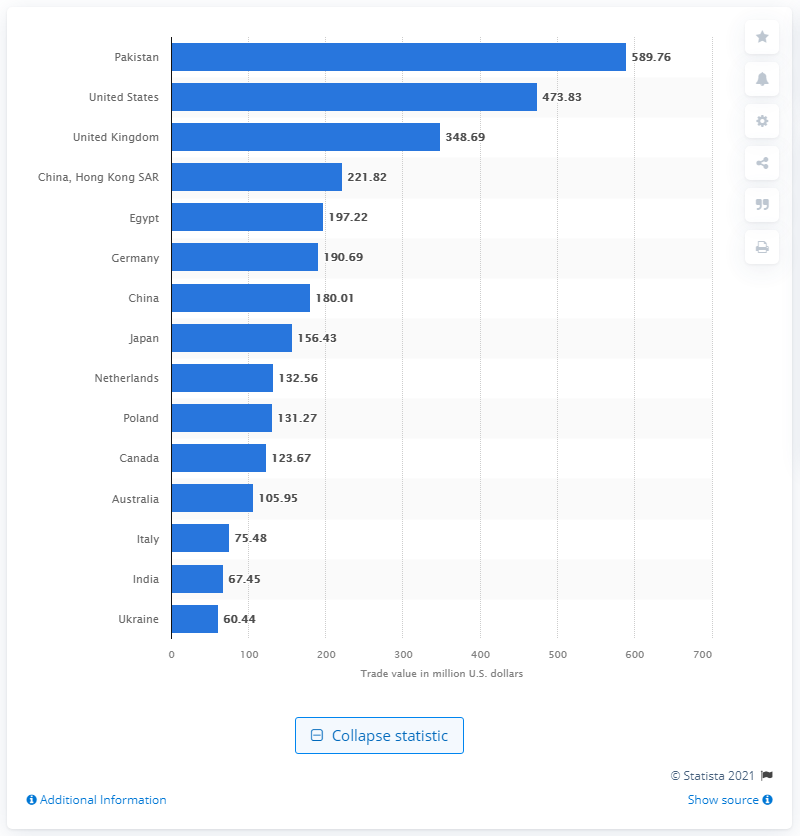Indicate a few pertinent items in this graphic. Pakistan was the leading tea importer in the world in 2020. In 2020, the value of Pakistan's tea imports in US dollars was approximately $589.76 million. In 2020, the value of Pakistan's tea imports in US dollars was approximately 473.83. 